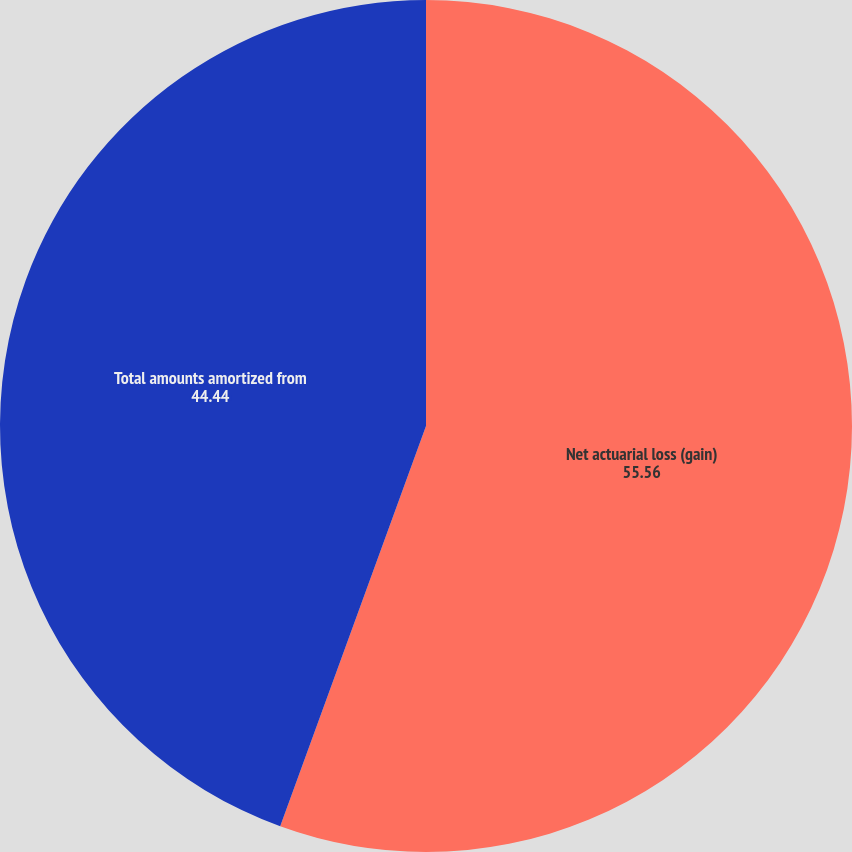Convert chart. <chart><loc_0><loc_0><loc_500><loc_500><pie_chart><fcel>Net actuarial loss (gain)<fcel>Total amounts amortized from<nl><fcel>55.56%<fcel>44.44%<nl></chart> 